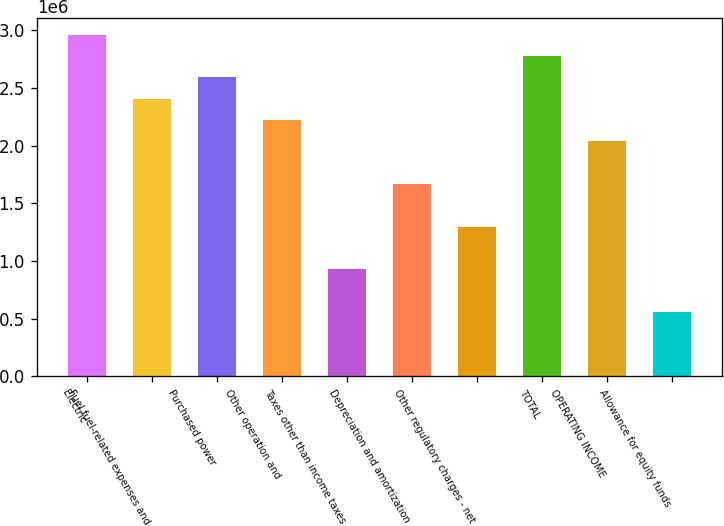<chart> <loc_0><loc_0><loc_500><loc_500><bar_chart><fcel>Electric<fcel>Fuel fuel-related expenses and<fcel>Purchased power<fcel>Other operation and<fcel>Taxes other than income taxes<fcel>Depreciation and amortization<fcel>Other regulatory charges - net<fcel>TOTAL<fcel>OPERATING INCOME<fcel>Allowance for equity funds<nl><fcel>2.96251e+06<fcel>2.40724e+06<fcel>2.59233e+06<fcel>2.22216e+06<fcel>926544<fcel>1.66689e+06<fcel>1.29672e+06<fcel>2.77742e+06<fcel>2.03707e+06<fcel>556369<nl></chart> 